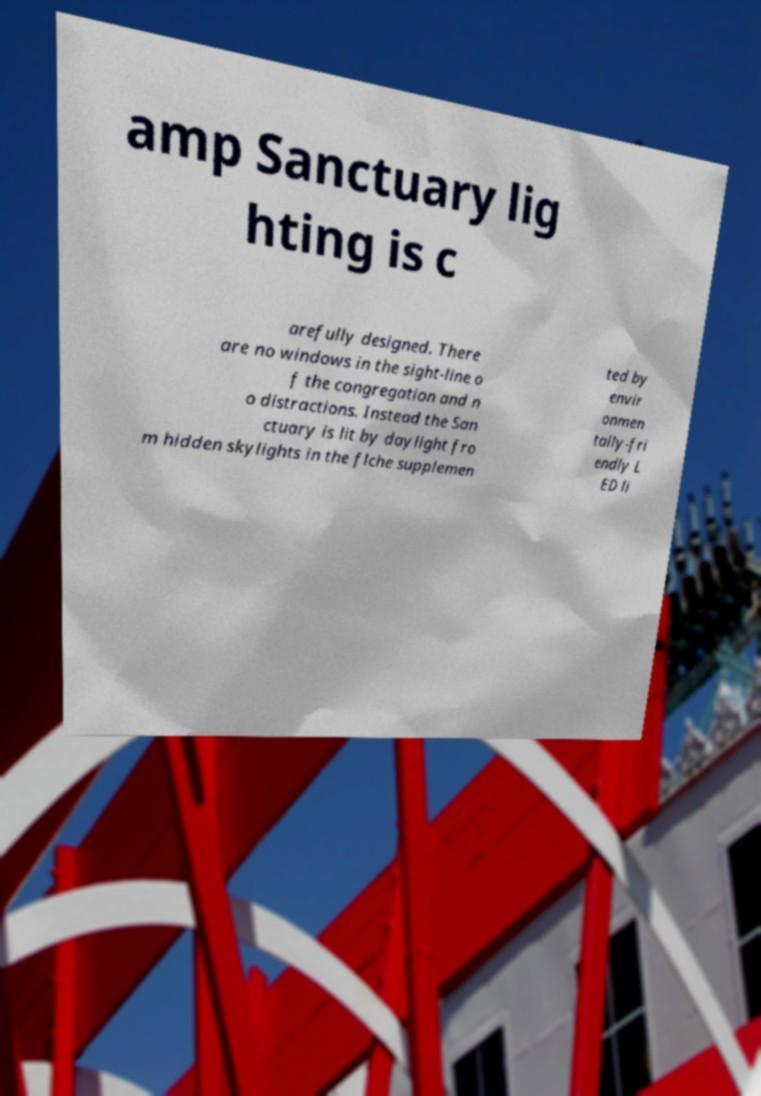Could you extract and type out the text from this image? amp Sanctuary lig hting is c arefully designed. There are no windows in the sight-line o f the congregation and n o distractions. Instead the San ctuary is lit by daylight fro m hidden skylights in the flche supplemen ted by envir onmen tally-fri endly L ED li 